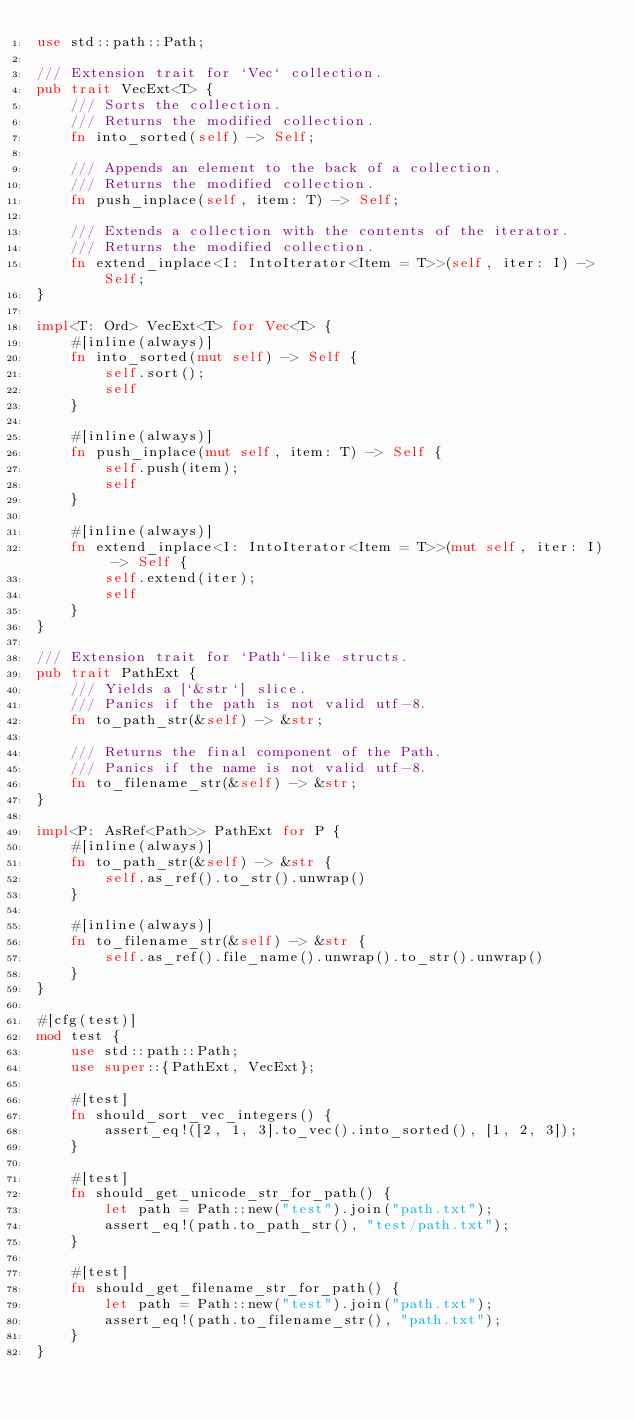<code> <loc_0><loc_0><loc_500><loc_500><_Rust_>use std::path::Path;

/// Extension trait for `Vec` collection.
pub trait VecExt<T> {
    /// Sorts the collection.
    /// Returns the modified collection.
    fn into_sorted(self) -> Self;

    /// Appends an element to the back of a collection.
    /// Returns the modified collection.
    fn push_inplace(self, item: T) -> Self;

    /// Extends a collection with the contents of the iterator.
    /// Returns the modified collection.
    fn extend_inplace<I: IntoIterator<Item = T>>(self, iter: I) -> Self;
}

impl<T: Ord> VecExt<T> for Vec<T> {
    #[inline(always)]
    fn into_sorted(mut self) -> Self {
        self.sort();
        self
    }

    #[inline(always)]
    fn push_inplace(mut self, item: T) -> Self {
        self.push(item);
        self
    }

    #[inline(always)]
    fn extend_inplace<I: IntoIterator<Item = T>>(mut self, iter: I) -> Self {
        self.extend(iter);
        self
    }
}

/// Extension trait for `Path`-like structs.
pub trait PathExt {
    /// Yields a [`&str`] slice.
    /// Panics if the path is not valid utf-8.
    fn to_path_str(&self) -> &str;

    /// Returns the final component of the Path.
    /// Panics if the name is not valid utf-8.
    fn to_filename_str(&self) -> &str;
}

impl<P: AsRef<Path>> PathExt for P {
    #[inline(always)]
    fn to_path_str(&self) -> &str {
        self.as_ref().to_str().unwrap()
    }

    #[inline(always)]
    fn to_filename_str(&self) -> &str {
        self.as_ref().file_name().unwrap().to_str().unwrap()
    }
}

#[cfg(test)]
mod test {
    use std::path::Path;
    use super::{PathExt, VecExt};

    #[test]
    fn should_sort_vec_integers() {
        assert_eq!([2, 1, 3].to_vec().into_sorted(), [1, 2, 3]);
    }

    #[test]
    fn should_get_unicode_str_for_path() {
        let path = Path::new("test").join("path.txt");
        assert_eq!(path.to_path_str(), "test/path.txt");
    }

    #[test]
    fn should_get_filename_str_for_path() {
        let path = Path::new("test").join("path.txt");
        assert_eq!(path.to_filename_str(), "path.txt");
    }
}
</code> 